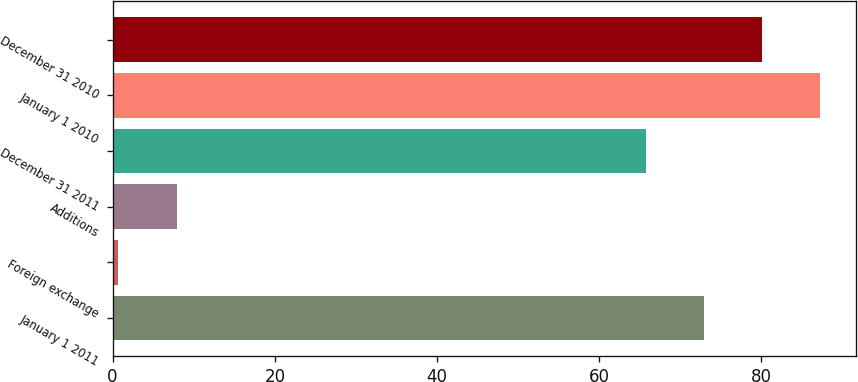Convert chart to OTSL. <chart><loc_0><loc_0><loc_500><loc_500><bar_chart><fcel>January 1 2011<fcel>Foreign exchange<fcel>Additions<fcel>December 31 2011<fcel>January 1 2010<fcel>December 31 2010<nl><fcel>72.88<fcel>0.7<fcel>7.88<fcel>65.7<fcel>87.24<fcel>80.06<nl></chart> 